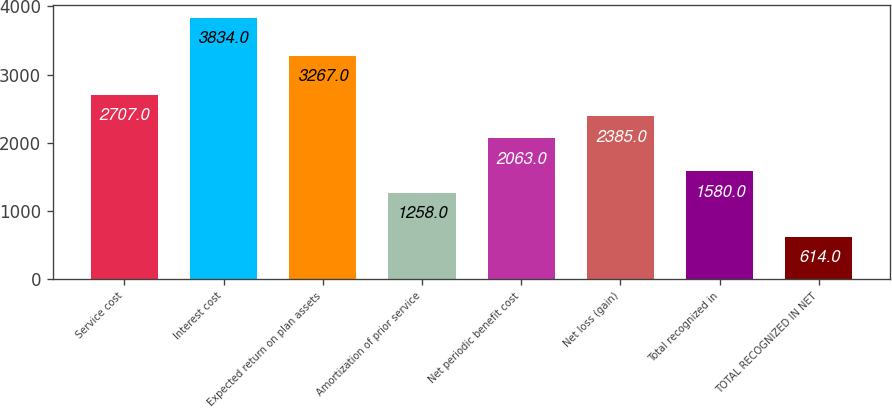<chart> <loc_0><loc_0><loc_500><loc_500><bar_chart><fcel>Service cost<fcel>Interest cost<fcel>Expected return on plan assets<fcel>Amortization of prior service<fcel>Net periodic benefit cost<fcel>Net loss (gain)<fcel>Total recognized in<fcel>TOTAL RECOGNIZED IN NET<nl><fcel>2707<fcel>3834<fcel>3267<fcel>1258<fcel>2063<fcel>2385<fcel>1580<fcel>614<nl></chart> 